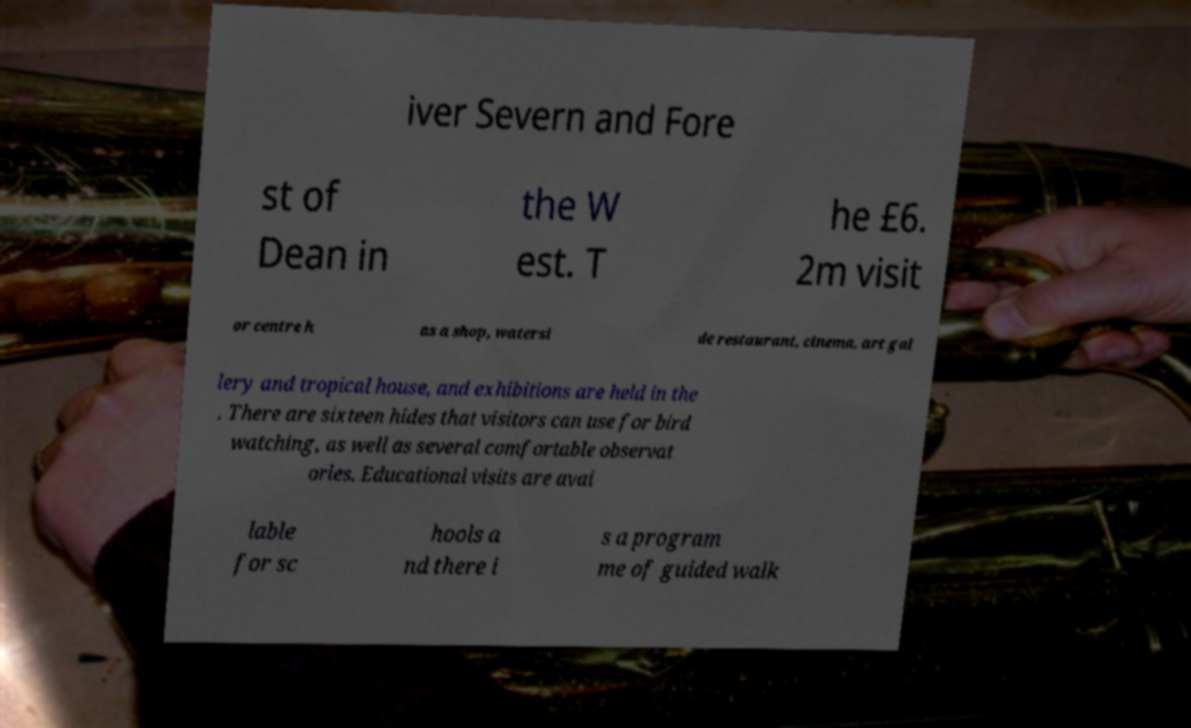Please identify and transcribe the text found in this image. iver Severn and Fore st of Dean in the W est. T he £6. 2m visit or centre h as a shop, watersi de restaurant, cinema, art gal lery and tropical house, and exhibitions are held in the . There are sixteen hides that visitors can use for bird watching, as well as several comfortable observat ories. Educational visits are avai lable for sc hools a nd there i s a program me of guided walk 